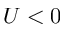<formula> <loc_0><loc_0><loc_500><loc_500>U < 0</formula> 